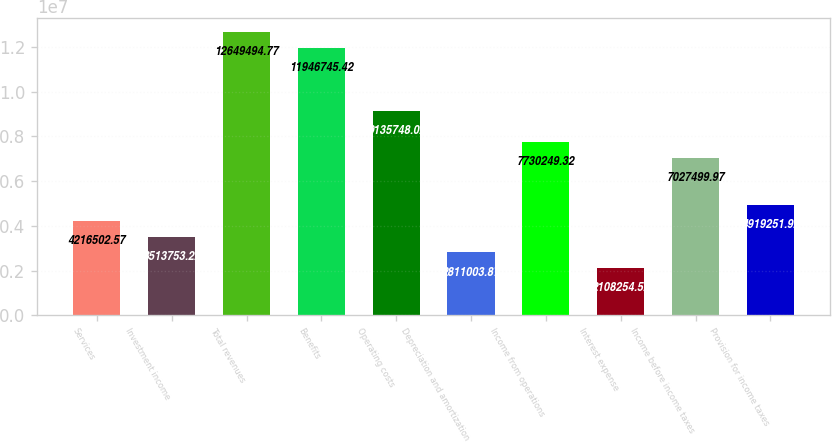<chart> <loc_0><loc_0><loc_500><loc_500><bar_chart><fcel>Services<fcel>Investment income<fcel>Total revenues<fcel>Benefits<fcel>Operating costs<fcel>Depreciation and amortization<fcel>Income from operations<fcel>Interest expense<fcel>Income before income taxes<fcel>Provision for income taxes<nl><fcel>4.2165e+06<fcel>3.51375e+06<fcel>1.26495e+07<fcel>1.19467e+07<fcel>9.13575e+06<fcel>2.811e+06<fcel>7.73025e+06<fcel>2.10825e+06<fcel>7.0275e+06<fcel>4.91925e+06<nl></chart> 